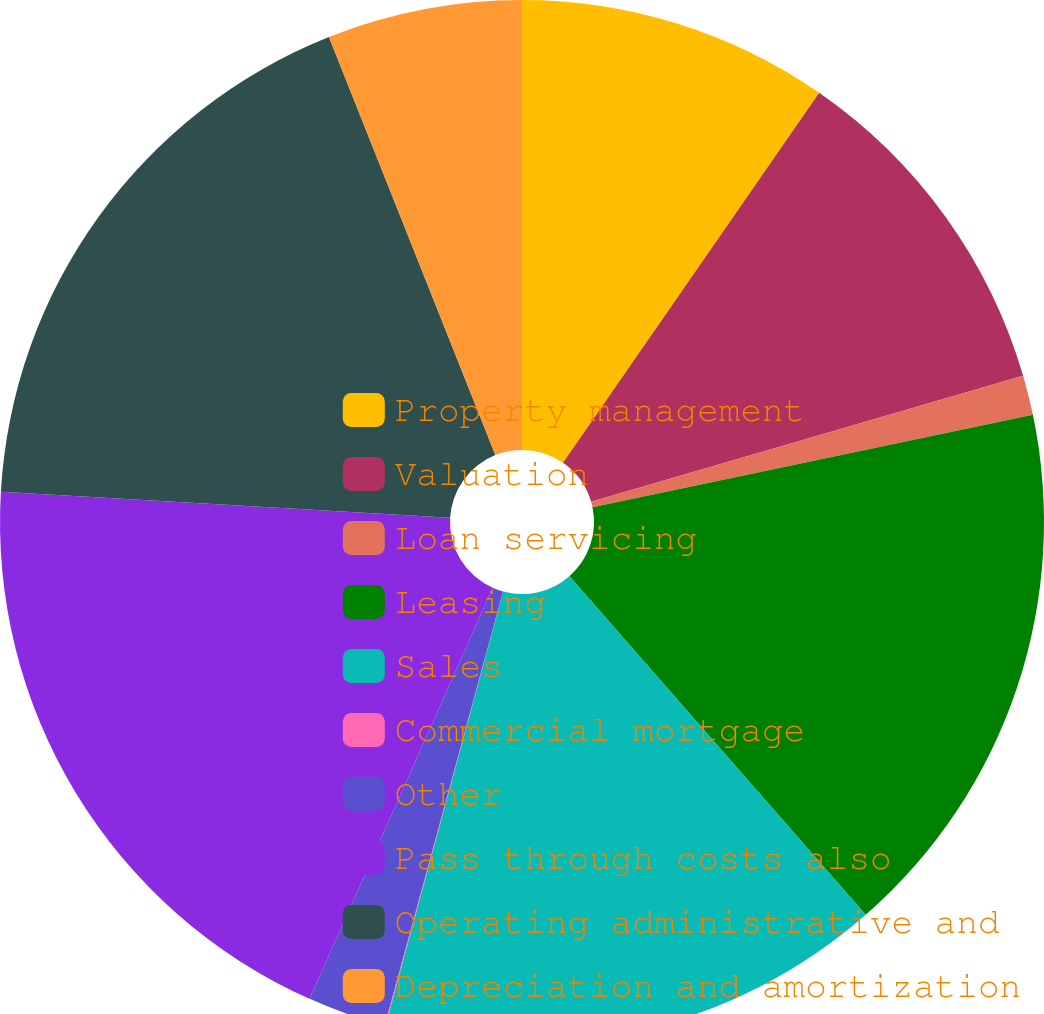<chart> <loc_0><loc_0><loc_500><loc_500><pie_chart><fcel>Property management<fcel>Valuation<fcel>Loan servicing<fcel>Leasing<fcel>Sales<fcel>Commercial mortgage<fcel>Other<fcel>Pass through costs also<fcel>Operating administrative and<fcel>Depreciation and amortization<nl><fcel>9.64%<fcel>10.84%<fcel>1.23%<fcel>16.85%<fcel>15.65%<fcel>0.03%<fcel>2.43%<fcel>19.25%<fcel>18.05%<fcel>6.03%<nl></chart> 